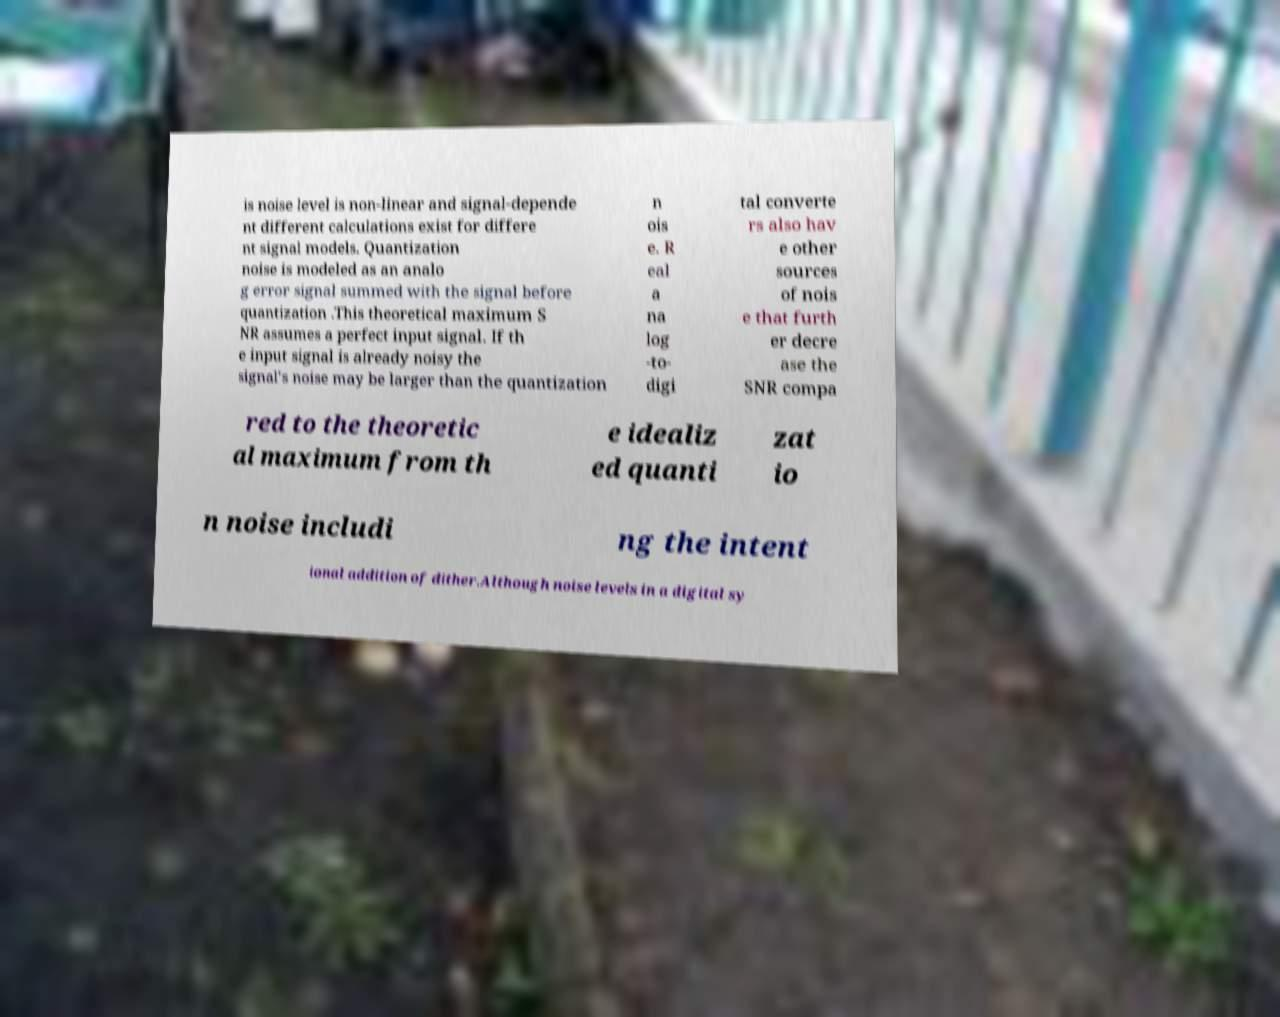What messages or text are displayed in this image? I need them in a readable, typed format. is noise level is non-linear and signal-depende nt different calculations exist for differe nt signal models. Quantization noise is modeled as an analo g error signal summed with the signal before quantization .This theoretical maximum S NR assumes a perfect input signal. If th e input signal is already noisy the signal's noise may be larger than the quantization n ois e. R eal a na log -to- digi tal converte rs also hav e other sources of nois e that furth er decre ase the SNR compa red to the theoretic al maximum from th e idealiz ed quanti zat io n noise includi ng the intent ional addition of dither.Although noise levels in a digital sy 